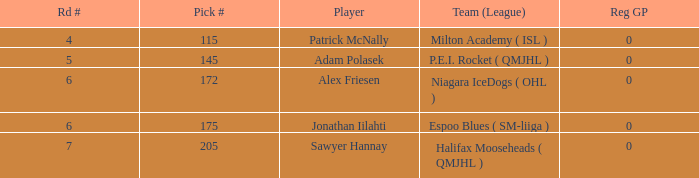What's sawyer hannay's total pick number? 1.0. 